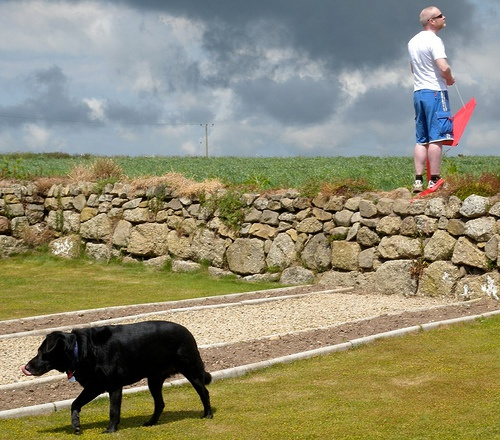Describe the objects in this image and their specific colors. I can see dog in gray, black, darkgreen, and maroon tones, people in gray, white, darkgray, blue, and lightpink tones, and kite in gray, salmon, and brown tones in this image. 